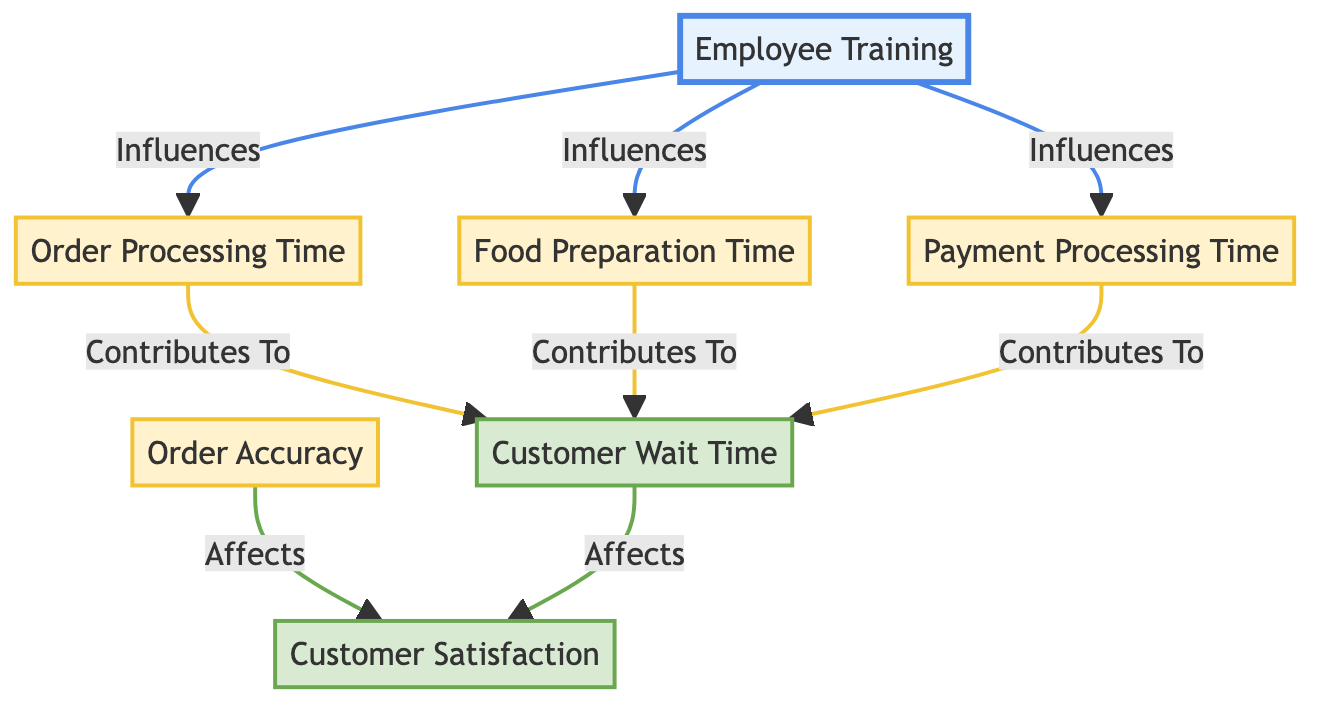What is the first node in the flowchart? The first node is "Employee Training," which is positioned at the top of the flowchart. It serves as the starting point that influences several downstream processes.
Answer: Employee Training How many process nodes are there in the diagram? The process nodes include "Order Processing Time," "Food Preparation Time," "Payment Processing Time," and "Order Accuracy." Thus, there are four process nodes.
Answer: Four Which node contributes to customer wait time besides order processing? The node "Food Preparation Time" contributes to customer wait time in addition to "Order Processing Time." Both nodes directly link to the "Customer Wait Time" outcome.
Answer: Food Preparation Time What is the relationship between order accuracy and customer satisfaction? The relationship is that "Order Accuracy Affects Customer Satisfaction," indicating that the accuracy of orders plays a role in determining how satisfied customers feel.
Answer: Affects What influences payment processing time? The diagram does not explicitly list any nodes that influence payment processing time; it positions payment processing as an independent process that receives influence from "Employee Training."
Answer: Employee Training How does customer wait time affect customer satisfaction? The diagram indicates that "Customer Wait Time Affects Customer Satisfaction," showing that the time customers wait impacts their overall satisfaction with the service.
Answer: Affects Which node is the last outcome in the flowchart? The last outcome node in the flowchart is "Customer Satisfaction," which follows the "Customer Wait Time" node, indicating that it is the final metric assessed in relation to drive-thru operations.
Answer: Customer Satisfaction What contributes to customer wait time? The factors that contribute to customer wait time include "Order Processing Time," "Food Preparation Time," and "Payment Processing Time." These three nodes feed directly into the customer wait time outcome.
Answer: Order Processing Time, Food Preparation Time, Payment Processing Time What type of diagram is this? This diagram is a flowchart designed to represent the relationship between different metrics and processes within employee efficiency for drive-thru operations.
Answer: Flowchart 